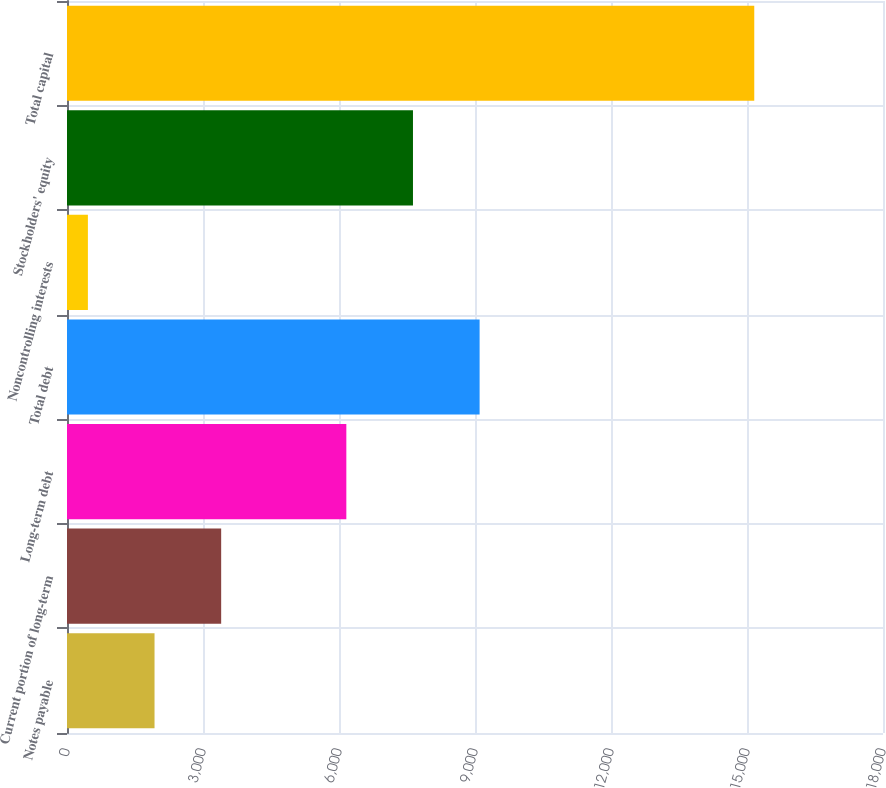Convert chart to OTSL. <chart><loc_0><loc_0><loc_500><loc_500><bar_chart><fcel>Notes payable<fcel>Current portion of long-term<fcel>Long-term debt<fcel>Total debt<fcel>Noncontrolling interests<fcel>Stockholders' equity<fcel>Total capital<nl><fcel>1930.91<fcel>3400.82<fcel>6161.9<fcel>9101.72<fcel>461<fcel>7631.81<fcel>15160.1<nl></chart> 